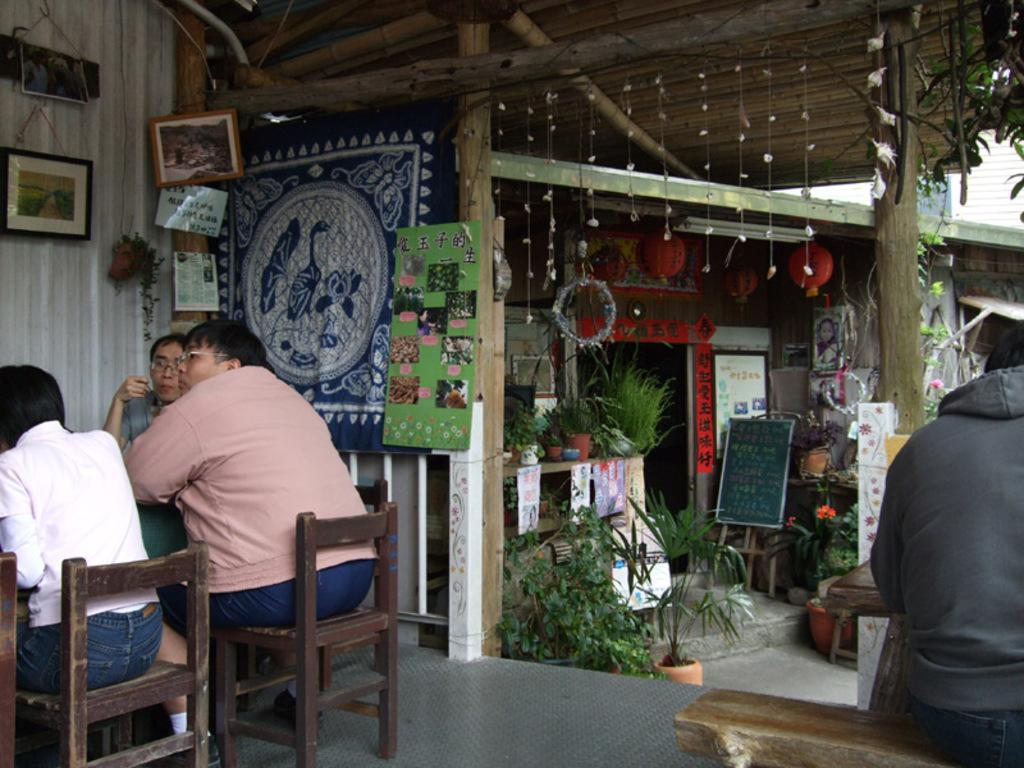Who or what can be seen in the image? There are people in the image. What are the people doing in the image? The people are sitting on chairs. What type of structure is visible in the image? There is a wooden building in the image. What type of quince is being used as a prop in the image? There is no quince present in the image. Is the image a work of fiction or non-fiction? The image itself is neither fiction nor non-fiction; it is a photograph or illustration. --- Facts: 1. There is a car in the image. 2. The car is red. 3. The car has four wheels. 4. There is a road in the image. 5. The road is paved. Absurd Topics: parrot, ocean, dance Conversation: What is the main subject of the image? The main subject of the image is a car. What color is the car? The car is red. How many wheels does the car have? The car has four wheels. What type of surface is visible in the image? There is a road in the image, and it is paved. Reasoning: Let's think step by step in order to produce the conversation. We start by identifying the main subject in the image, which is the car. Then, we describe the car's color and the number of wheels it has. Finally, we mention the road as an additional feature in the image, noting that it is paved. Each question is designed to elicit a specific detail about the image that is known from the provided facts. Absurd Question/Answer: Can you see a parrot flying over the car in the image? No, there is no parrot present in the image. Is the car driving along the ocean in the image? No, the image does not show the car near an ocean or any body of water. 